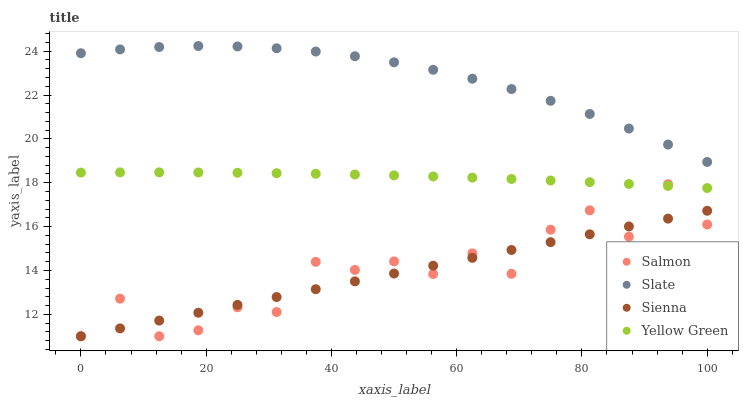Does Sienna have the minimum area under the curve?
Answer yes or no. Yes. Does Slate have the maximum area under the curve?
Answer yes or no. Yes. Does Salmon have the minimum area under the curve?
Answer yes or no. No. Does Salmon have the maximum area under the curve?
Answer yes or no. No. Is Sienna the smoothest?
Answer yes or no. Yes. Is Salmon the roughest?
Answer yes or no. Yes. Is Slate the smoothest?
Answer yes or no. No. Is Slate the roughest?
Answer yes or no. No. Does Sienna have the lowest value?
Answer yes or no. Yes. Does Slate have the lowest value?
Answer yes or no. No. Does Slate have the highest value?
Answer yes or no. Yes. Does Salmon have the highest value?
Answer yes or no. No. Is Salmon less than Slate?
Answer yes or no. Yes. Is Yellow Green greater than Sienna?
Answer yes or no. Yes. Does Salmon intersect Sienna?
Answer yes or no. Yes. Is Salmon less than Sienna?
Answer yes or no. No. Is Salmon greater than Sienna?
Answer yes or no. No. Does Salmon intersect Slate?
Answer yes or no. No. 